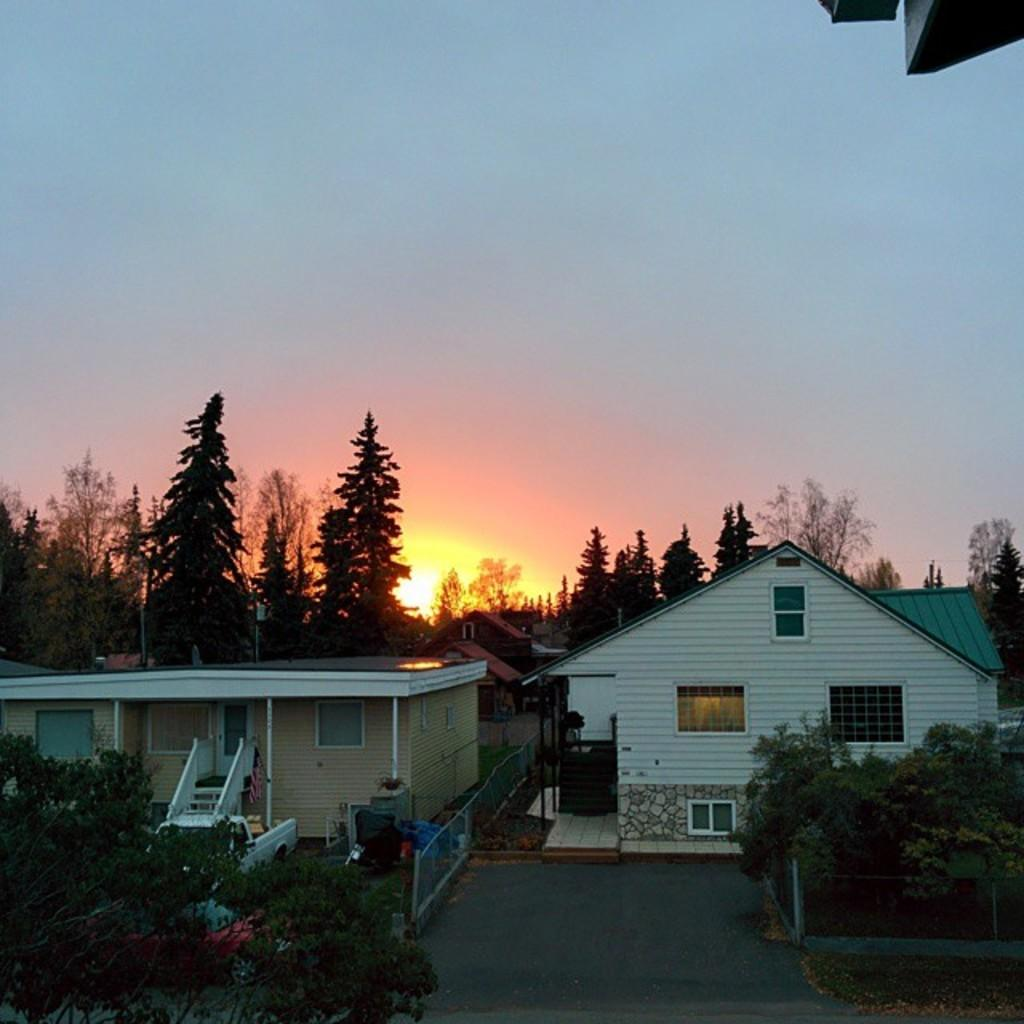What type of structures can be seen in the image? There are houses in the image. What other natural elements are present in the image? There are trees in the image. Are there any man-made objects visible in the image? Yes, there are vehicles in the image. What is visible at the top of the image? The sky is visible at the top of the image. What time of day is depicted in the image? The image depicts a sunset. What type of texture can be seen on the skirt in the image? There is no skirt present in the image; it features houses, trees, vehicles, and a sunset. 